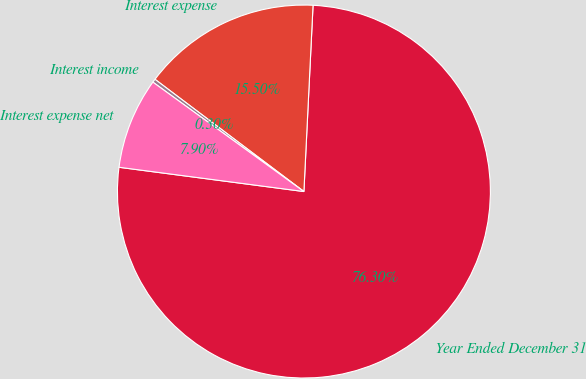Convert chart to OTSL. <chart><loc_0><loc_0><loc_500><loc_500><pie_chart><fcel>Year Ended December 31<fcel>Interest expense<fcel>Interest income<fcel>Interest expense net<nl><fcel>76.29%<fcel>15.5%<fcel>0.3%<fcel>7.9%<nl></chart> 